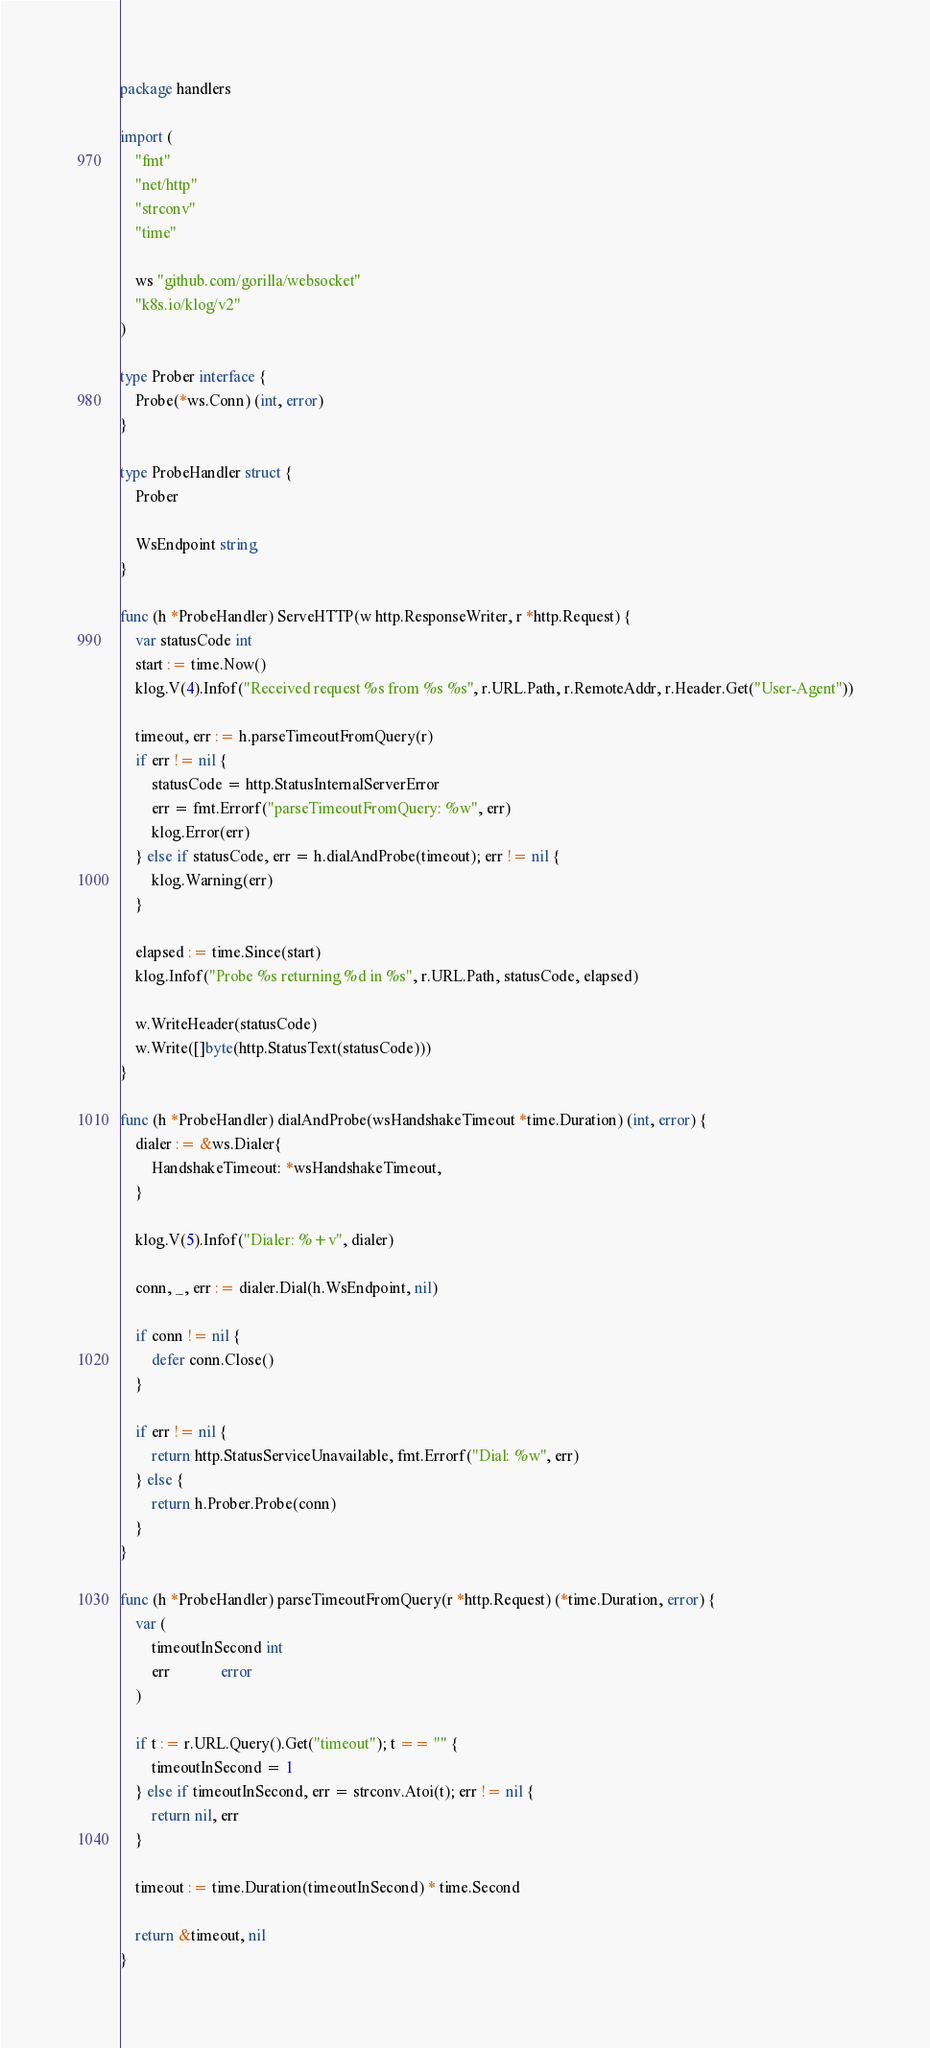<code> <loc_0><loc_0><loc_500><loc_500><_Go_>package handlers

import (
	"fmt"
	"net/http"
	"strconv"
	"time"

	ws "github.com/gorilla/websocket"
	"k8s.io/klog/v2"
)

type Prober interface {
	Probe(*ws.Conn) (int, error)
}

type ProbeHandler struct {
	Prober

	WsEndpoint string
}

func (h *ProbeHandler) ServeHTTP(w http.ResponseWriter, r *http.Request) {
	var statusCode int
	start := time.Now()
	klog.V(4).Infof("Received request %s from %s %s", r.URL.Path, r.RemoteAddr, r.Header.Get("User-Agent"))

	timeout, err := h.parseTimeoutFromQuery(r)
	if err != nil {
		statusCode = http.StatusInternalServerError
		err = fmt.Errorf("parseTimeoutFromQuery: %w", err)
		klog.Error(err)
	} else if statusCode, err = h.dialAndProbe(timeout); err != nil {
		klog.Warning(err)
	}

	elapsed := time.Since(start)
	klog.Infof("Probe %s returning %d in %s", r.URL.Path, statusCode, elapsed)

	w.WriteHeader(statusCode)
	w.Write([]byte(http.StatusText(statusCode)))
}

func (h *ProbeHandler) dialAndProbe(wsHandshakeTimeout *time.Duration) (int, error) {
	dialer := &ws.Dialer{
		HandshakeTimeout: *wsHandshakeTimeout,
	}

	klog.V(5).Infof("Dialer: %+v", dialer)

	conn, _, err := dialer.Dial(h.WsEndpoint, nil)

	if conn != nil {
		defer conn.Close()
	}

	if err != nil {
		return http.StatusServiceUnavailable, fmt.Errorf("Dial: %w", err)
	} else {
		return h.Prober.Probe(conn)
	}
}

func (h *ProbeHandler) parseTimeoutFromQuery(r *http.Request) (*time.Duration, error) {
	var (
		timeoutInSecond int
		err             error
	)

	if t := r.URL.Query().Get("timeout"); t == "" {
		timeoutInSecond = 1
	} else if timeoutInSecond, err = strconv.Atoi(t); err != nil {
		return nil, err
	}

	timeout := time.Duration(timeoutInSecond) * time.Second

	return &timeout, nil
}
</code> 